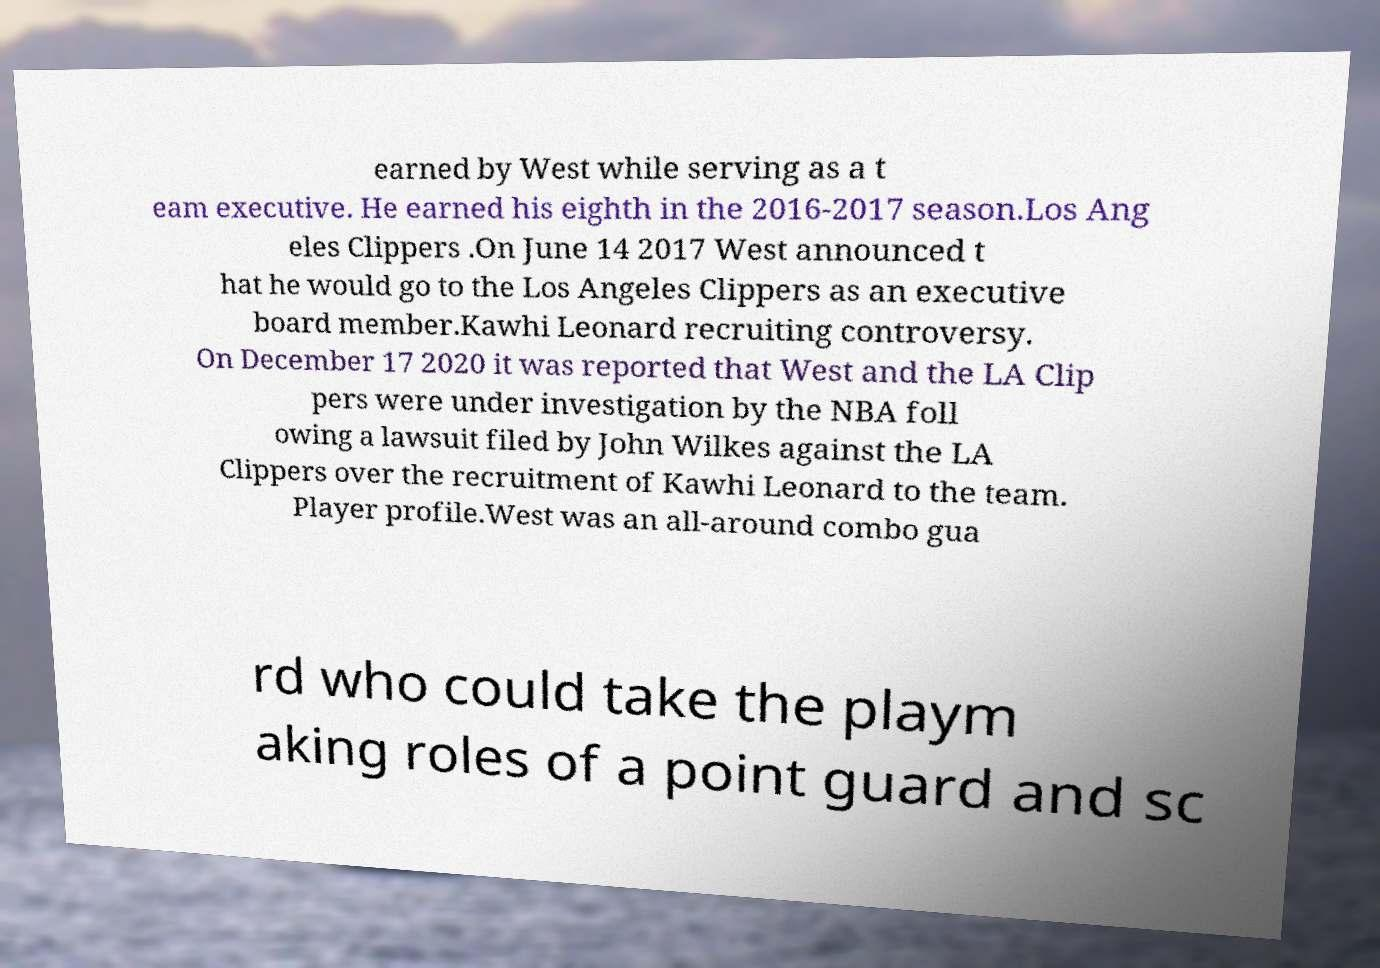What messages or text are displayed in this image? I need them in a readable, typed format. earned by West while serving as a t eam executive. He earned his eighth in the 2016-2017 season.Los Ang eles Clippers .On June 14 2017 West announced t hat he would go to the Los Angeles Clippers as an executive board member.Kawhi Leonard recruiting controversy. On December 17 2020 it was reported that West and the LA Clip pers were under investigation by the NBA foll owing a lawsuit filed by John Wilkes against the LA Clippers over the recruitment of Kawhi Leonard to the team. Player profile.West was an all-around combo gua rd who could take the playm aking roles of a point guard and sc 